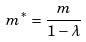<formula> <loc_0><loc_0><loc_500><loc_500>m ^ { * } = \frac { m } { 1 - \lambda }</formula> 